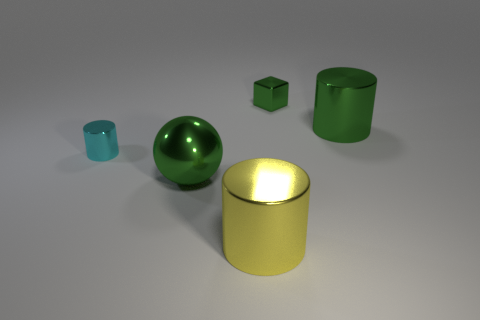Add 3 tiny cyan rubber cylinders. How many objects exist? 8 Subtract all blocks. How many objects are left? 4 Subtract 0 blue balls. How many objects are left? 5 Subtract all large green metallic objects. Subtract all large gray cubes. How many objects are left? 3 Add 2 large green objects. How many large green objects are left? 4 Add 1 balls. How many balls exist? 2 